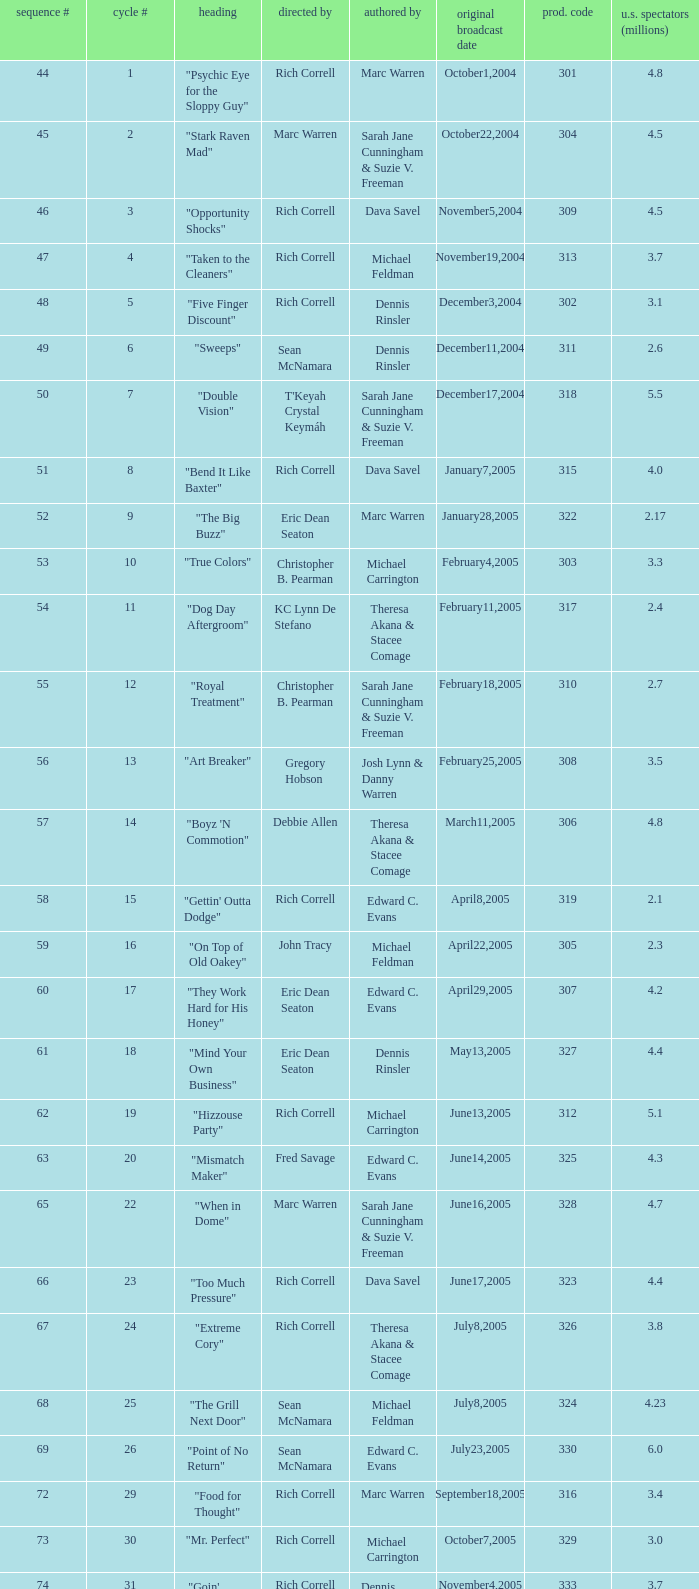What is the title of the episode directed by Rich Correll and written by Dennis Rinsler? "Five Finger Discount". 